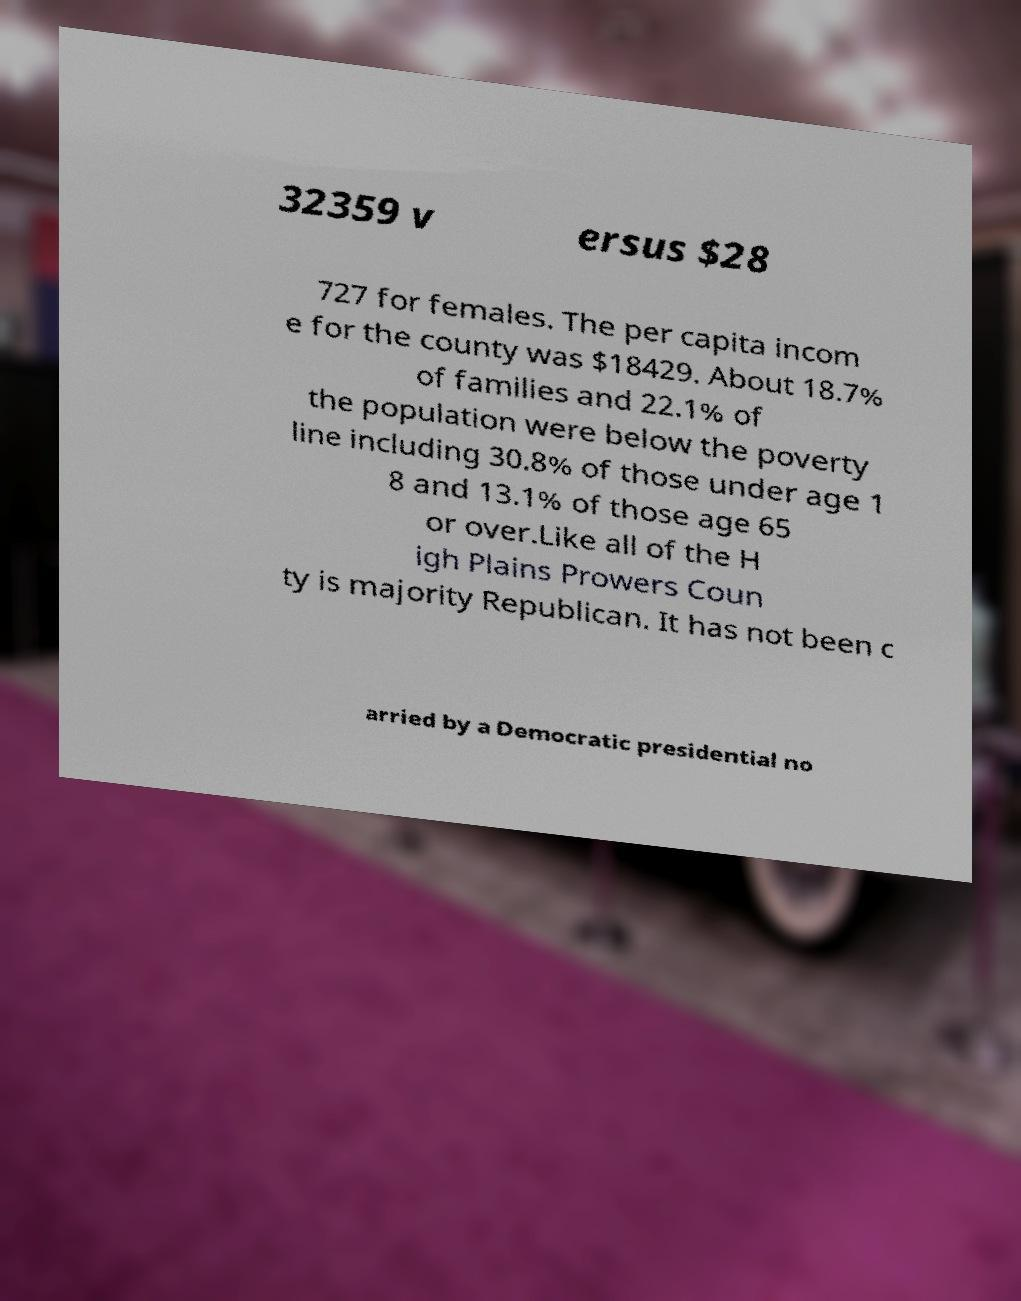Can you read and provide the text displayed in the image?This photo seems to have some interesting text. Can you extract and type it out for me? 32359 v ersus $28 727 for females. The per capita incom e for the county was $18429. About 18.7% of families and 22.1% of the population were below the poverty line including 30.8% of those under age 1 8 and 13.1% of those age 65 or over.Like all of the H igh Plains Prowers Coun ty is majority Republican. It has not been c arried by a Democratic presidential no 